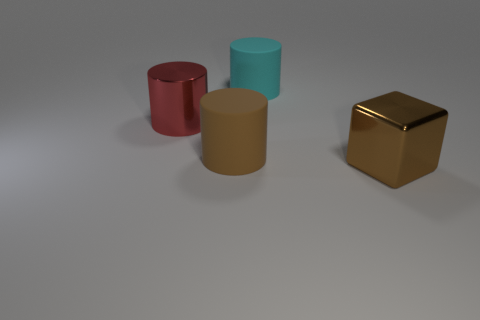Subtract all large brown matte cylinders. How many cylinders are left? 2 Add 2 metal cylinders. How many objects exist? 6 Subtract all brown cylinders. How many cylinders are left? 2 Subtract all big green things. Subtract all large brown matte objects. How many objects are left? 3 Add 3 big brown rubber cylinders. How many big brown rubber cylinders are left? 4 Add 4 brown metallic blocks. How many brown metallic blocks exist? 5 Subtract 0 gray cubes. How many objects are left? 4 Subtract all cubes. How many objects are left? 3 Subtract 1 cubes. How many cubes are left? 0 Subtract all brown cylinders. Subtract all brown spheres. How many cylinders are left? 2 